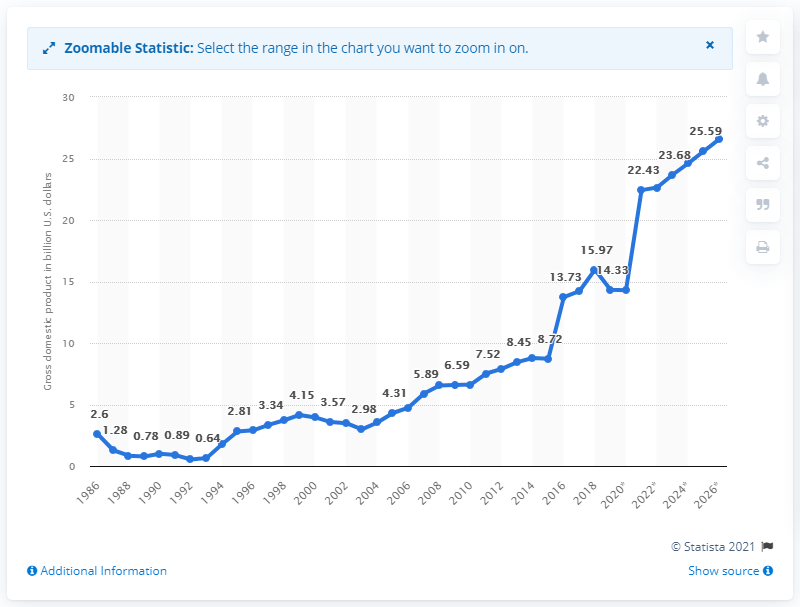List a handful of essential elements in this visual. Haiti's gross domestic product was valued at 14.29 billion dollars in 2019. 